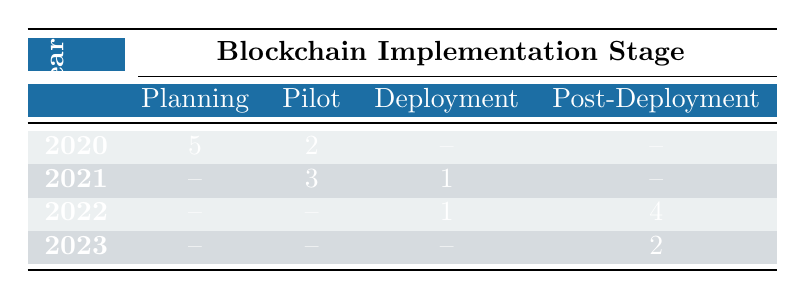What is the number of incidents reported in the year 2021 during the Pilot stage? In the table, we look at the row for the year 2021. Under the column for the Pilot stage, it shows 3 incidents reported.
Answer: 3 How many incidents were reported in total for the year 2022? We need to sum the incidents reported in 2022. There is 1 incident reported in the Deployment stage and 4 in the Post-Deployment stage, giving us a total of 1 + 4 = 5 incidents reported in 2022.
Answer: 5 Did the Blockchain Implementation stage "Full Integration" have any incidents reported in 2023? By checking the row for 2023, under the Full Integration stage, it shows 0 incidents reported. Hence, no incidents were reported in this stage for that year.
Answer: No What was the difference in reported incidents from the year 2020 to 2021? In 2020, there were a total of 7 incidents (5 in Planning + 2 in Pilot) and in 2021, there were a total of 4 incidents (3 in Pilot + 1 in Deployment). The difference is 7 - 4 = 3 incidents.
Answer: 3 How many total incidents were reported in the Post-Deployment stage over the years 2022 and 2023? In the table, for the Post-Deployment stage, there were 4 reported in 2022 and 2 reported in 2023. Adding these gives us 4 + 2 = 6 total incidents in the Post-Deployment stage over those two years.
Answer: 6 In which year did the highest number of incidents occur in the Planning stage? Looking at the rows for the Planning stage, it shows 5 incidents in 2020. This is the only year with reported incidents in this stage, and thus the highest.
Answer: 2020 What is the total number of incidents reported across all years in the Pilot stage? By examining the Pilot stage, we find 2 incidents in 2020, 3 incidents in 2021, and 0 in 2022 and 2023. Summing these gives us 2 + 3 + 0 + 0 = 5 incidents reported in total across all years for this stage.
Answer: 5 Was there any year in which the Deployment stage had more incidents than the Pilot stage? Reviewing the table, in 2021 there was 1 incident in Deployment and 3 in Pilot. In 2022, there was 1 incident in Deployment and none in Pilot. Thus, Deployment never had more incidents than Pilot in any year.
Answer: No 